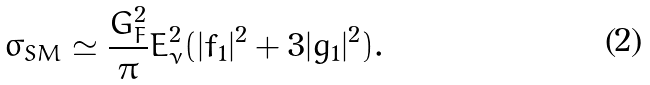<formula> <loc_0><loc_0><loc_500><loc_500>\sigma _ { S M } \simeq \frac { G _ { F } ^ { 2 } } { \pi } E _ { \nu } ^ { 2 } ( | f _ { 1 } | ^ { 2 } + 3 | g _ { 1 } | ^ { 2 } ) .</formula> 